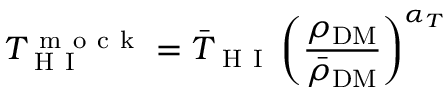<formula> <loc_0><loc_0><loc_500><loc_500>T _ { H I } ^ { m o c k } = \bar { T } _ { H I } \left ( \frac { \rho _ { D M } } { \bar { \rho } _ { D M } } \right ) ^ { \alpha _ { T } }</formula> 